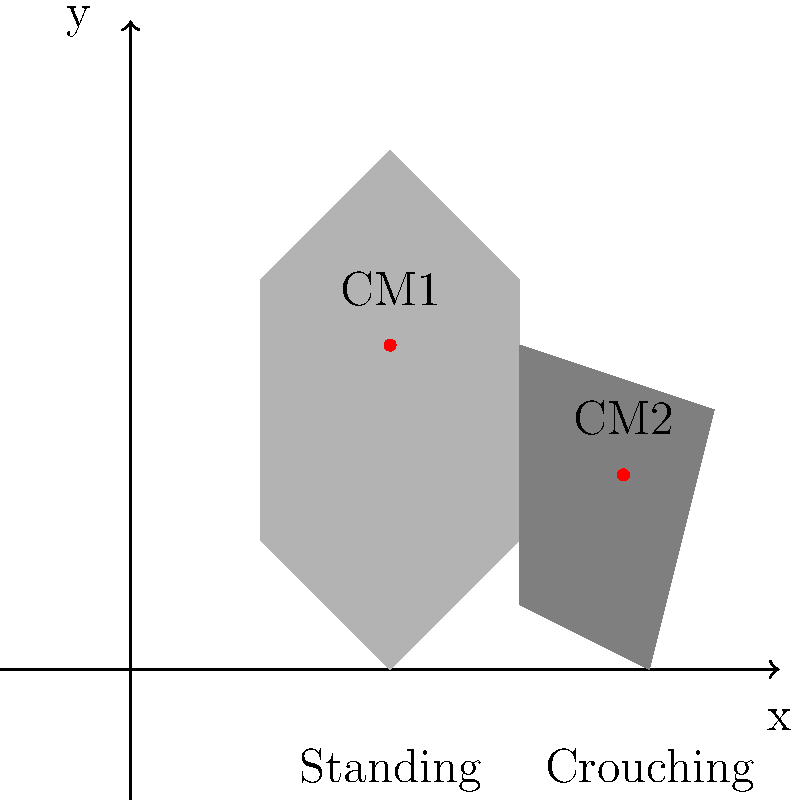As a judoka, you understand the importance of balance and body positioning. The diagram shows two stances: standing and crouching. If the center of mass (CM) in the standing position is at coordinates (2, 2.5) and in the crouching position at (3.8, 1.5), calculate the magnitude of the displacement vector of the center of mass when transitioning from standing to crouching stance. To solve this problem, we'll follow these steps:

1) Identify the coordinates:
   Standing CM: $(x_1, y_1) = (2, 2.5)$
   Crouching CM: $(x_2, y_2) = (3.8, 1.5)$

2) Calculate the displacement in x and y directions:
   $\Delta x = x_2 - x_1 = 3.8 - 2 = 1.8$
   $\Delta y = y_2 - y_1 = 1.5 - 2.5 = -1$

3) Use the displacement vector formula:
   $\vec{d} = (\Delta x, \Delta y) = (1.8, -1)$

4) Calculate the magnitude of the displacement vector using the Pythagorean theorem:
   $|\vec{d}| = \sqrt{(\Delta x)^2 + (\Delta y)^2}$
   $|\vec{d}| = \sqrt{(1.8)^2 + (-1)^2}$
   $|\vec{d}| = \sqrt{3.24 + 1}$
   $|\vec{d}| = \sqrt{4.24}$
   $|\vec{d}| \approx 2.059$

5) Round to two decimal places:
   $|\vec{d}| \approx 2.06$

Thus, the magnitude of the displacement vector of the center of mass when transitioning from standing to crouching stance is approximately 2.06 units.
Answer: 2.06 units 